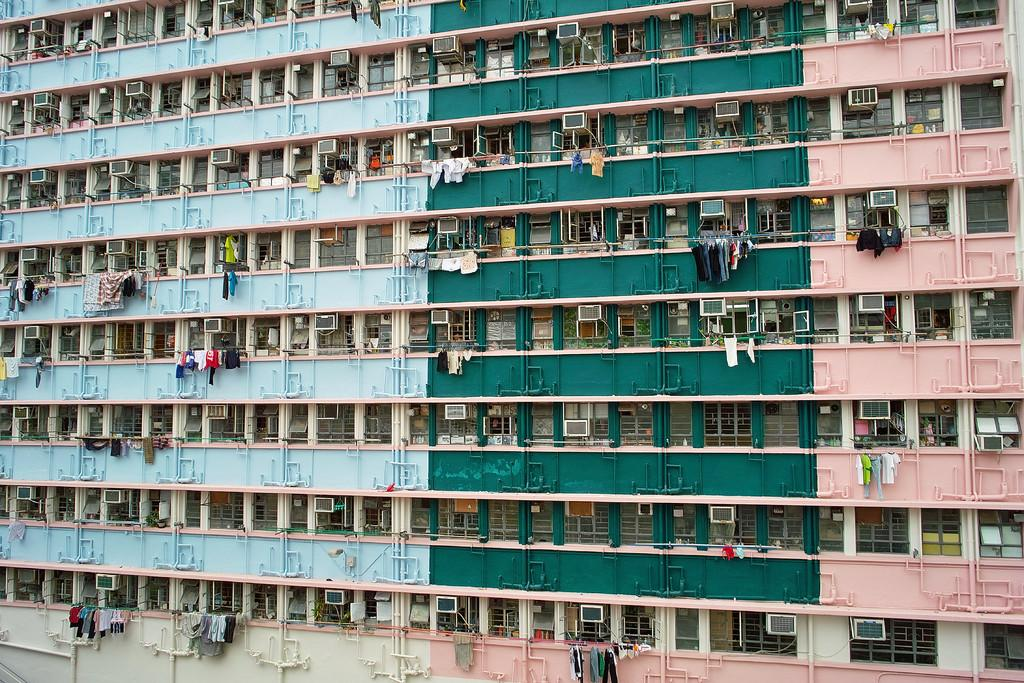What type of structure is in the image? There is a building in the image. What colors are used on the building? The building has green, pink, and blue colors. What else can be seen in the image besides the building? There are clothes in multi-color and pipes visible in the image. What architectural features are present in the image? There are pillars visible in the image. Can you tell me how many people are swinging on the border in the image? There is no swing or border present in the image. What type of muscle can be seen flexing in the image? There are no muscles visible in the image; it features a building, clothes, pipes, and pillars. 